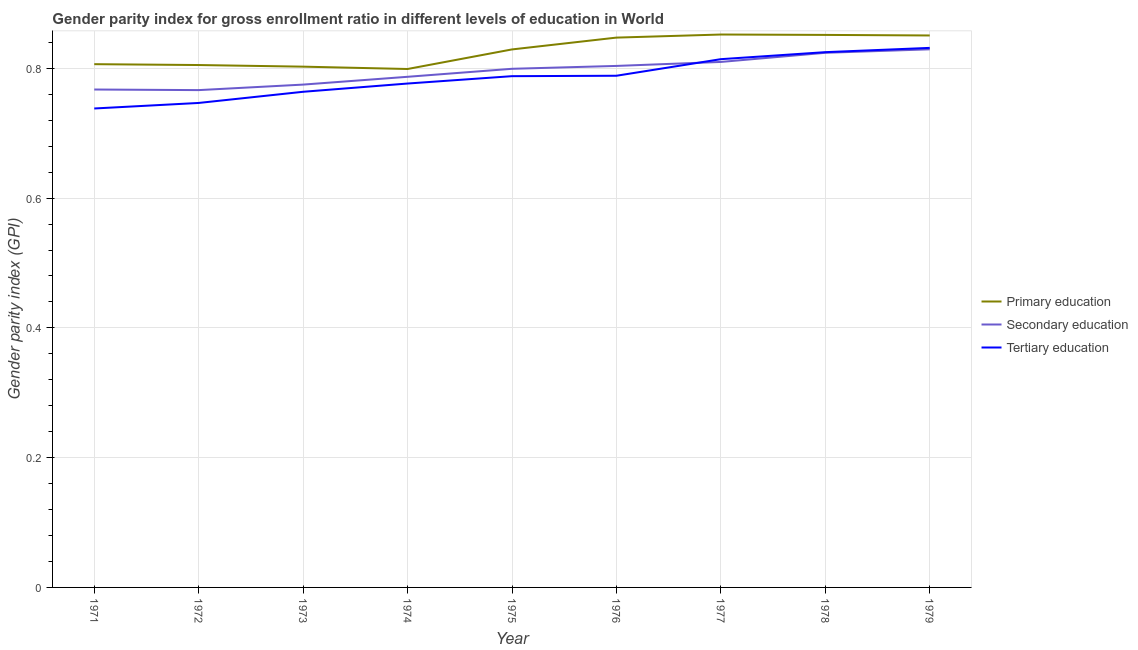Does the line corresponding to gender parity index in primary education intersect with the line corresponding to gender parity index in secondary education?
Your answer should be very brief. No. What is the gender parity index in primary education in 1976?
Offer a terse response. 0.85. Across all years, what is the maximum gender parity index in tertiary education?
Offer a terse response. 0.83. Across all years, what is the minimum gender parity index in secondary education?
Keep it short and to the point. 0.77. In which year was the gender parity index in tertiary education maximum?
Provide a succinct answer. 1979. In which year was the gender parity index in primary education minimum?
Provide a short and direct response. 1974. What is the total gender parity index in secondary education in the graph?
Provide a succinct answer. 7.16. What is the difference between the gender parity index in secondary education in 1974 and that in 1977?
Keep it short and to the point. -0.02. What is the difference between the gender parity index in tertiary education in 1975 and the gender parity index in primary education in 1972?
Offer a very short reply. -0.02. What is the average gender parity index in primary education per year?
Provide a short and direct response. 0.83. In the year 1976, what is the difference between the gender parity index in primary education and gender parity index in tertiary education?
Provide a short and direct response. 0.06. In how many years, is the gender parity index in primary education greater than 0.32?
Give a very brief answer. 9. What is the ratio of the gender parity index in secondary education in 1972 to that in 1976?
Give a very brief answer. 0.95. Is the difference between the gender parity index in tertiary education in 1974 and 1979 greater than the difference between the gender parity index in primary education in 1974 and 1979?
Provide a short and direct response. No. What is the difference between the highest and the second highest gender parity index in primary education?
Give a very brief answer. 0. What is the difference between the highest and the lowest gender parity index in secondary education?
Offer a very short reply. 0.06. In how many years, is the gender parity index in primary education greater than the average gender parity index in primary education taken over all years?
Provide a short and direct response. 5. Is the gender parity index in secondary education strictly greater than the gender parity index in tertiary education over the years?
Ensure brevity in your answer.  No. Is the gender parity index in secondary education strictly less than the gender parity index in tertiary education over the years?
Keep it short and to the point. No. Are the values on the major ticks of Y-axis written in scientific E-notation?
Your answer should be compact. No. Where does the legend appear in the graph?
Make the answer very short. Center right. How many legend labels are there?
Offer a terse response. 3. How are the legend labels stacked?
Offer a very short reply. Vertical. What is the title of the graph?
Your response must be concise. Gender parity index for gross enrollment ratio in different levels of education in World. Does "Methane" appear as one of the legend labels in the graph?
Offer a terse response. No. What is the label or title of the Y-axis?
Offer a very short reply. Gender parity index (GPI). What is the Gender parity index (GPI) of Primary education in 1971?
Provide a succinct answer. 0.81. What is the Gender parity index (GPI) of Secondary education in 1971?
Your answer should be very brief. 0.77. What is the Gender parity index (GPI) of Tertiary education in 1971?
Your answer should be very brief. 0.74. What is the Gender parity index (GPI) in Primary education in 1972?
Give a very brief answer. 0.81. What is the Gender parity index (GPI) in Secondary education in 1972?
Provide a short and direct response. 0.77. What is the Gender parity index (GPI) of Tertiary education in 1972?
Keep it short and to the point. 0.75. What is the Gender parity index (GPI) in Primary education in 1973?
Ensure brevity in your answer.  0.8. What is the Gender parity index (GPI) of Secondary education in 1973?
Provide a short and direct response. 0.77. What is the Gender parity index (GPI) of Tertiary education in 1973?
Keep it short and to the point. 0.76. What is the Gender parity index (GPI) of Primary education in 1974?
Give a very brief answer. 0.8. What is the Gender parity index (GPI) in Secondary education in 1974?
Your response must be concise. 0.79. What is the Gender parity index (GPI) in Tertiary education in 1974?
Provide a short and direct response. 0.78. What is the Gender parity index (GPI) in Primary education in 1975?
Provide a short and direct response. 0.83. What is the Gender parity index (GPI) in Secondary education in 1975?
Offer a very short reply. 0.8. What is the Gender parity index (GPI) of Tertiary education in 1975?
Offer a very short reply. 0.79. What is the Gender parity index (GPI) of Primary education in 1976?
Give a very brief answer. 0.85. What is the Gender parity index (GPI) of Secondary education in 1976?
Provide a succinct answer. 0.8. What is the Gender parity index (GPI) in Tertiary education in 1976?
Your answer should be very brief. 0.79. What is the Gender parity index (GPI) in Primary education in 1977?
Offer a terse response. 0.85. What is the Gender parity index (GPI) in Secondary education in 1977?
Ensure brevity in your answer.  0.81. What is the Gender parity index (GPI) of Tertiary education in 1977?
Give a very brief answer. 0.81. What is the Gender parity index (GPI) in Primary education in 1978?
Make the answer very short. 0.85. What is the Gender parity index (GPI) of Secondary education in 1978?
Offer a terse response. 0.82. What is the Gender parity index (GPI) in Tertiary education in 1978?
Ensure brevity in your answer.  0.82. What is the Gender parity index (GPI) of Primary education in 1979?
Make the answer very short. 0.85. What is the Gender parity index (GPI) of Secondary education in 1979?
Your answer should be compact. 0.83. What is the Gender parity index (GPI) of Tertiary education in 1979?
Keep it short and to the point. 0.83. Across all years, what is the maximum Gender parity index (GPI) of Primary education?
Provide a short and direct response. 0.85. Across all years, what is the maximum Gender parity index (GPI) in Secondary education?
Offer a terse response. 0.83. Across all years, what is the maximum Gender parity index (GPI) of Tertiary education?
Offer a very short reply. 0.83. Across all years, what is the minimum Gender parity index (GPI) of Primary education?
Provide a short and direct response. 0.8. Across all years, what is the minimum Gender parity index (GPI) of Secondary education?
Your answer should be compact. 0.77. Across all years, what is the minimum Gender parity index (GPI) of Tertiary education?
Your answer should be compact. 0.74. What is the total Gender parity index (GPI) of Primary education in the graph?
Make the answer very short. 7.44. What is the total Gender parity index (GPI) of Secondary education in the graph?
Offer a terse response. 7.16. What is the total Gender parity index (GPI) in Tertiary education in the graph?
Your answer should be very brief. 7.07. What is the difference between the Gender parity index (GPI) in Primary education in 1971 and that in 1972?
Make the answer very short. 0. What is the difference between the Gender parity index (GPI) in Secondary education in 1971 and that in 1972?
Give a very brief answer. 0. What is the difference between the Gender parity index (GPI) of Tertiary education in 1971 and that in 1972?
Offer a terse response. -0.01. What is the difference between the Gender parity index (GPI) of Primary education in 1971 and that in 1973?
Offer a terse response. 0. What is the difference between the Gender parity index (GPI) of Secondary education in 1971 and that in 1973?
Provide a short and direct response. -0.01. What is the difference between the Gender parity index (GPI) in Tertiary education in 1971 and that in 1973?
Ensure brevity in your answer.  -0.03. What is the difference between the Gender parity index (GPI) in Primary education in 1971 and that in 1974?
Your answer should be very brief. 0.01. What is the difference between the Gender parity index (GPI) in Secondary education in 1971 and that in 1974?
Your answer should be compact. -0.02. What is the difference between the Gender parity index (GPI) in Tertiary education in 1971 and that in 1974?
Your response must be concise. -0.04. What is the difference between the Gender parity index (GPI) of Primary education in 1971 and that in 1975?
Ensure brevity in your answer.  -0.02. What is the difference between the Gender parity index (GPI) in Secondary education in 1971 and that in 1975?
Your answer should be very brief. -0.03. What is the difference between the Gender parity index (GPI) in Tertiary education in 1971 and that in 1975?
Provide a succinct answer. -0.05. What is the difference between the Gender parity index (GPI) of Primary education in 1971 and that in 1976?
Your answer should be compact. -0.04. What is the difference between the Gender parity index (GPI) of Secondary education in 1971 and that in 1976?
Provide a succinct answer. -0.04. What is the difference between the Gender parity index (GPI) in Tertiary education in 1971 and that in 1976?
Your answer should be very brief. -0.05. What is the difference between the Gender parity index (GPI) in Primary education in 1971 and that in 1977?
Your response must be concise. -0.05. What is the difference between the Gender parity index (GPI) in Secondary education in 1971 and that in 1977?
Ensure brevity in your answer.  -0.04. What is the difference between the Gender parity index (GPI) in Tertiary education in 1971 and that in 1977?
Give a very brief answer. -0.08. What is the difference between the Gender parity index (GPI) in Primary education in 1971 and that in 1978?
Offer a very short reply. -0.05. What is the difference between the Gender parity index (GPI) of Secondary education in 1971 and that in 1978?
Give a very brief answer. -0.06. What is the difference between the Gender parity index (GPI) in Tertiary education in 1971 and that in 1978?
Offer a very short reply. -0.09. What is the difference between the Gender parity index (GPI) of Primary education in 1971 and that in 1979?
Provide a succinct answer. -0.04. What is the difference between the Gender parity index (GPI) of Secondary education in 1971 and that in 1979?
Ensure brevity in your answer.  -0.06. What is the difference between the Gender parity index (GPI) in Tertiary education in 1971 and that in 1979?
Provide a short and direct response. -0.09. What is the difference between the Gender parity index (GPI) in Primary education in 1972 and that in 1973?
Your response must be concise. 0. What is the difference between the Gender parity index (GPI) in Secondary education in 1972 and that in 1973?
Offer a terse response. -0.01. What is the difference between the Gender parity index (GPI) of Tertiary education in 1972 and that in 1973?
Give a very brief answer. -0.02. What is the difference between the Gender parity index (GPI) in Primary education in 1972 and that in 1974?
Provide a succinct answer. 0.01. What is the difference between the Gender parity index (GPI) in Secondary education in 1972 and that in 1974?
Offer a terse response. -0.02. What is the difference between the Gender parity index (GPI) in Tertiary education in 1972 and that in 1974?
Offer a terse response. -0.03. What is the difference between the Gender parity index (GPI) in Primary education in 1972 and that in 1975?
Ensure brevity in your answer.  -0.02. What is the difference between the Gender parity index (GPI) in Secondary education in 1972 and that in 1975?
Your response must be concise. -0.03. What is the difference between the Gender parity index (GPI) in Tertiary education in 1972 and that in 1975?
Offer a very short reply. -0.04. What is the difference between the Gender parity index (GPI) in Primary education in 1972 and that in 1976?
Offer a terse response. -0.04. What is the difference between the Gender parity index (GPI) of Secondary education in 1972 and that in 1976?
Provide a short and direct response. -0.04. What is the difference between the Gender parity index (GPI) in Tertiary education in 1972 and that in 1976?
Ensure brevity in your answer.  -0.04. What is the difference between the Gender parity index (GPI) of Primary education in 1972 and that in 1977?
Provide a short and direct response. -0.05. What is the difference between the Gender parity index (GPI) in Secondary education in 1972 and that in 1977?
Your response must be concise. -0.04. What is the difference between the Gender parity index (GPI) in Tertiary education in 1972 and that in 1977?
Make the answer very short. -0.07. What is the difference between the Gender parity index (GPI) of Primary education in 1972 and that in 1978?
Offer a terse response. -0.05. What is the difference between the Gender parity index (GPI) of Secondary education in 1972 and that in 1978?
Your answer should be very brief. -0.06. What is the difference between the Gender parity index (GPI) of Tertiary education in 1972 and that in 1978?
Give a very brief answer. -0.08. What is the difference between the Gender parity index (GPI) in Primary education in 1972 and that in 1979?
Your response must be concise. -0.05. What is the difference between the Gender parity index (GPI) in Secondary education in 1972 and that in 1979?
Provide a succinct answer. -0.06. What is the difference between the Gender parity index (GPI) in Tertiary education in 1972 and that in 1979?
Your response must be concise. -0.08. What is the difference between the Gender parity index (GPI) of Primary education in 1973 and that in 1974?
Your answer should be very brief. 0. What is the difference between the Gender parity index (GPI) in Secondary education in 1973 and that in 1974?
Offer a very short reply. -0.01. What is the difference between the Gender parity index (GPI) in Tertiary education in 1973 and that in 1974?
Your response must be concise. -0.01. What is the difference between the Gender parity index (GPI) of Primary education in 1973 and that in 1975?
Keep it short and to the point. -0.03. What is the difference between the Gender parity index (GPI) in Secondary education in 1973 and that in 1975?
Ensure brevity in your answer.  -0.02. What is the difference between the Gender parity index (GPI) in Tertiary education in 1973 and that in 1975?
Your answer should be compact. -0.02. What is the difference between the Gender parity index (GPI) in Primary education in 1973 and that in 1976?
Provide a short and direct response. -0.04. What is the difference between the Gender parity index (GPI) of Secondary education in 1973 and that in 1976?
Make the answer very short. -0.03. What is the difference between the Gender parity index (GPI) in Tertiary education in 1973 and that in 1976?
Your answer should be very brief. -0.02. What is the difference between the Gender parity index (GPI) in Primary education in 1973 and that in 1977?
Ensure brevity in your answer.  -0.05. What is the difference between the Gender parity index (GPI) in Secondary education in 1973 and that in 1977?
Provide a succinct answer. -0.03. What is the difference between the Gender parity index (GPI) of Tertiary education in 1973 and that in 1977?
Provide a short and direct response. -0.05. What is the difference between the Gender parity index (GPI) in Primary education in 1973 and that in 1978?
Make the answer very short. -0.05. What is the difference between the Gender parity index (GPI) in Secondary education in 1973 and that in 1978?
Keep it short and to the point. -0.05. What is the difference between the Gender parity index (GPI) of Tertiary education in 1973 and that in 1978?
Your answer should be very brief. -0.06. What is the difference between the Gender parity index (GPI) of Primary education in 1973 and that in 1979?
Provide a short and direct response. -0.05. What is the difference between the Gender parity index (GPI) in Secondary education in 1973 and that in 1979?
Your answer should be compact. -0.05. What is the difference between the Gender parity index (GPI) in Tertiary education in 1973 and that in 1979?
Offer a very short reply. -0.07. What is the difference between the Gender parity index (GPI) of Primary education in 1974 and that in 1975?
Provide a succinct answer. -0.03. What is the difference between the Gender parity index (GPI) in Secondary education in 1974 and that in 1975?
Provide a succinct answer. -0.01. What is the difference between the Gender parity index (GPI) of Tertiary education in 1974 and that in 1975?
Your answer should be very brief. -0.01. What is the difference between the Gender parity index (GPI) of Primary education in 1974 and that in 1976?
Offer a very short reply. -0.05. What is the difference between the Gender parity index (GPI) in Secondary education in 1974 and that in 1976?
Your response must be concise. -0.02. What is the difference between the Gender parity index (GPI) in Tertiary education in 1974 and that in 1976?
Provide a short and direct response. -0.01. What is the difference between the Gender parity index (GPI) in Primary education in 1974 and that in 1977?
Your response must be concise. -0.05. What is the difference between the Gender parity index (GPI) of Secondary education in 1974 and that in 1977?
Provide a succinct answer. -0.02. What is the difference between the Gender parity index (GPI) of Tertiary education in 1974 and that in 1977?
Your answer should be compact. -0.04. What is the difference between the Gender parity index (GPI) in Primary education in 1974 and that in 1978?
Offer a terse response. -0.05. What is the difference between the Gender parity index (GPI) of Secondary education in 1974 and that in 1978?
Your response must be concise. -0.04. What is the difference between the Gender parity index (GPI) of Tertiary education in 1974 and that in 1978?
Offer a terse response. -0.05. What is the difference between the Gender parity index (GPI) of Primary education in 1974 and that in 1979?
Your response must be concise. -0.05. What is the difference between the Gender parity index (GPI) in Secondary education in 1974 and that in 1979?
Ensure brevity in your answer.  -0.04. What is the difference between the Gender parity index (GPI) of Tertiary education in 1974 and that in 1979?
Provide a short and direct response. -0.06. What is the difference between the Gender parity index (GPI) of Primary education in 1975 and that in 1976?
Your answer should be compact. -0.02. What is the difference between the Gender parity index (GPI) in Secondary education in 1975 and that in 1976?
Provide a short and direct response. -0. What is the difference between the Gender parity index (GPI) in Tertiary education in 1975 and that in 1976?
Your answer should be compact. -0. What is the difference between the Gender parity index (GPI) in Primary education in 1975 and that in 1977?
Your response must be concise. -0.02. What is the difference between the Gender parity index (GPI) of Secondary education in 1975 and that in 1977?
Offer a very short reply. -0.01. What is the difference between the Gender parity index (GPI) in Tertiary education in 1975 and that in 1977?
Make the answer very short. -0.03. What is the difference between the Gender parity index (GPI) of Primary education in 1975 and that in 1978?
Keep it short and to the point. -0.02. What is the difference between the Gender parity index (GPI) of Secondary education in 1975 and that in 1978?
Ensure brevity in your answer.  -0.02. What is the difference between the Gender parity index (GPI) in Tertiary education in 1975 and that in 1978?
Offer a very short reply. -0.04. What is the difference between the Gender parity index (GPI) of Primary education in 1975 and that in 1979?
Offer a terse response. -0.02. What is the difference between the Gender parity index (GPI) of Secondary education in 1975 and that in 1979?
Offer a very short reply. -0.03. What is the difference between the Gender parity index (GPI) of Tertiary education in 1975 and that in 1979?
Your answer should be compact. -0.04. What is the difference between the Gender parity index (GPI) in Primary education in 1976 and that in 1977?
Give a very brief answer. -0. What is the difference between the Gender parity index (GPI) in Secondary education in 1976 and that in 1977?
Make the answer very short. -0.01. What is the difference between the Gender parity index (GPI) in Tertiary education in 1976 and that in 1977?
Your answer should be very brief. -0.03. What is the difference between the Gender parity index (GPI) of Primary education in 1976 and that in 1978?
Provide a succinct answer. -0. What is the difference between the Gender parity index (GPI) of Secondary education in 1976 and that in 1978?
Your answer should be compact. -0.02. What is the difference between the Gender parity index (GPI) of Tertiary education in 1976 and that in 1978?
Your response must be concise. -0.04. What is the difference between the Gender parity index (GPI) in Primary education in 1976 and that in 1979?
Keep it short and to the point. -0. What is the difference between the Gender parity index (GPI) in Secondary education in 1976 and that in 1979?
Keep it short and to the point. -0.03. What is the difference between the Gender parity index (GPI) in Tertiary education in 1976 and that in 1979?
Offer a very short reply. -0.04. What is the difference between the Gender parity index (GPI) in Primary education in 1977 and that in 1978?
Your response must be concise. 0. What is the difference between the Gender parity index (GPI) in Secondary education in 1977 and that in 1978?
Make the answer very short. -0.01. What is the difference between the Gender parity index (GPI) of Tertiary education in 1977 and that in 1978?
Make the answer very short. -0.01. What is the difference between the Gender parity index (GPI) of Primary education in 1977 and that in 1979?
Your answer should be compact. 0. What is the difference between the Gender parity index (GPI) in Secondary education in 1977 and that in 1979?
Your answer should be compact. -0.02. What is the difference between the Gender parity index (GPI) in Tertiary education in 1977 and that in 1979?
Your answer should be very brief. -0.02. What is the difference between the Gender parity index (GPI) in Primary education in 1978 and that in 1979?
Give a very brief answer. 0. What is the difference between the Gender parity index (GPI) of Secondary education in 1978 and that in 1979?
Your answer should be very brief. -0.01. What is the difference between the Gender parity index (GPI) of Tertiary education in 1978 and that in 1979?
Offer a very short reply. -0.01. What is the difference between the Gender parity index (GPI) of Primary education in 1971 and the Gender parity index (GPI) of Secondary education in 1972?
Offer a terse response. 0.04. What is the difference between the Gender parity index (GPI) of Primary education in 1971 and the Gender parity index (GPI) of Tertiary education in 1972?
Keep it short and to the point. 0.06. What is the difference between the Gender parity index (GPI) in Secondary education in 1971 and the Gender parity index (GPI) in Tertiary education in 1972?
Keep it short and to the point. 0.02. What is the difference between the Gender parity index (GPI) of Primary education in 1971 and the Gender parity index (GPI) of Secondary education in 1973?
Offer a terse response. 0.03. What is the difference between the Gender parity index (GPI) in Primary education in 1971 and the Gender parity index (GPI) in Tertiary education in 1973?
Give a very brief answer. 0.04. What is the difference between the Gender parity index (GPI) in Secondary education in 1971 and the Gender parity index (GPI) in Tertiary education in 1973?
Your response must be concise. 0. What is the difference between the Gender parity index (GPI) in Primary education in 1971 and the Gender parity index (GPI) in Secondary education in 1974?
Your response must be concise. 0.02. What is the difference between the Gender parity index (GPI) of Primary education in 1971 and the Gender parity index (GPI) of Tertiary education in 1974?
Your answer should be compact. 0.03. What is the difference between the Gender parity index (GPI) in Secondary education in 1971 and the Gender parity index (GPI) in Tertiary education in 1974?
Your response must be concise. -0.01. What is the difference between the Gender parity index (GPI) in Primary education in 1971 and the Gender parity index (GPI) in Secondary education in 1975?
Provide a succinct answer. 0.01. What is the difference between the Gender parity index (GPI) of Primary education in 1971 and the Gender parity index (GPI) of Tertiary education in 1975?
Make the answer very short. 0.02. What is the difference between the Gender parity index (GPI) of Secondary education in 1971 and the Gender parity index (GPI) of Tertiary education in 1975?
Provide a short and direct response. -0.02. What is the difference between the Gender parity index (GPI) in Primary education in 1971 and the Gender parity index (GPI) in Secondary education in 1976?
Provide a short and direct response. 0. What is the difference between the Gender parity index (GPI) of Primary education in 1971 and the Gender parity index (GPI) of Tertiary education in 1976?
Keep it short and to the point. 0.02. What is the difference between the Gender parity index (GPI) in Secondary education in 1971 and the Gender parity index (GPI) in Tertiary education in 1976?
Your answer should be very brief. -0.02. What is the difference between the Gender parity index (GPI) of Primary education in 1971 and the Gender parity index (GPI) of Secondary education in 1977?
Offer a terse response. -0. What is the difference between the Gender parity index (GPI) of Primary education in 1971 and the Gender parity index (GPI) of Tertiary education in 1977?
Provide a short and direct response. -0.01. What is the difference between the Gender parity index (GPI) in Secondary education in 1971 and the Gender parity index (GPI) in Tertiary education in 1977?
Your response must be concise. -0.05. What is the difference between the Gender parity index (GPI) in Primary education in 1971 and the Gender parity index (GPI) in Secondary education in 1978?
Offer a very short reply. -0.02. What is the difference between the Gender parity index (GPI) in Primary education in 1971 and the Gender parity index (GPI) in Tertiary education in 1978?
Offer a terse response. -0.02. What is the difference between the Gender parity index (GPI) of Secondary education in 1971 and the Gender parity index (GPI) of Tertiary education in 1978?
Your answer should be compact. -0.06. What is the difference between the Gender parity index (GPI) in Primary education in 1971 and the Gender parity index (GPI) in Secondary education in 1979?
Your answer should be very brief. -0.02. What is the difference between the Gender parity index (GPI) of Primary education in 1971 and the Gender parity index (GPI) of Tertiary education in 1979?
Your answer should be compact. -0.03. What is the difference between the Gender parity index (GPI) of Secondary education in 1971 and the Gender parity index (GPI) of Tertiary education in 1979?
Offer a very short reply. -0.06. What is the difference between the Gender parity index (GPI) of Primary education in 1972 and the Gender parity index (GPI) of Secondary education in 1973?
Keep it short and to the point. 0.03. What is the difference between the Gender parity index (GPI) of Primary education in 1972 and the Gender parity index (GPI) of Tertiary education in 1973?
Keep it short and to the point. 0.04. What is the difference between the Gender parity index (GPI) in Secondary education in 1972 and the Gender parity index (GPI) in Tertiary education in 1973?
Your response must be concise. 0. What is the difference between the Gender parity index (GPI) of Primary education in 1972 and the Gender parity index (GPI) of Secondary education in 1974?
Provide a short and direct response. 0.02. What is the difference between the Gender parity index (GPI) in Primary education in 1972 and the Gender parity index (GPI) in Tertiary education in 1974?
Keep it short and to the point. 0.03. What is the difference between the Gender parity index (GPI) in Secondary education in 1972 and the Gender parity index (GPI) in Tertiary education in 1974?
Provide a short and direct response. -0.01. What is the difference between the Gender parity index (GPI) in Primary education in 1972 and the Gender parity index (GPI) in Secondary education in 1975?
Your answer should be very brief. 0.01. What is the difference between the Gender parity index (GPI) in Primary education in 1972 and the Gender parity index (GPI) in Tertiary education in 1975?
Keep it short and to the point. 0.02. What is the difference between the Gender parity index (GPI) of Secondary education in 1972 and the Gender parity index (GPI) of Tertiary education in 1975?
Your answer should be compact. -0.02. What is the difference between the Gender parity index (GPI) in Primary education in 1972 and the Gender parity index (GPI) in Secondary education in 1976?
Offer a terse response. 0. What is the difference between the Gender parity index (GPI) of Primary education in 1972 and the Gender parity index (GPI) of Tertiary education in 1976?
Your answer should be very brief. 0.02. What is the difference between the Gender parity index (GPI) of Secondary education in 1972 and the Gender parity index (GPI) of Tertiary education in 1976?
Keep it short and to the point. -0.02. What is the difference between the Gender parity index (GPI) of Primary education in 1972 and the Gender parity index (GPI) of Secondary education in 1977?
Give a very brief answer. -0. What is the difference between the Gender parity index (GPI) in Primary education in 1972 and the Gender parity index (GPI) in Tertiary education in 1977?
Your answer should be compact. -0.01. What is the difference between the Gender parity index (GPI) in Secondary education in 1972 and the Gender parity index (GPI) in Tertiary education in 1977?
Keep it short and to the point. -0.05. What is the difference between the Gender parity index (GPI) of Primary education in 1972 and the Gender parity index (GPI) of Secondary education in 1978?
Give a very brief answer. -0.02. What is the difference between the Gender parity index (GPI) in Primary education in 1972 and the Gender parity index (GPI) in Tertiary education in 1978?
Offer a very short reply. -0.02. What is the difference between the Gender parity index (GPI) of Secondary education in 1972 and the Gender parity index (GPI) of Tertiary education in 1978?
Provide a short and direct response. -0.06. What is the difference between the Gender parity index (GPI) of Primary education in 1972 and the Gender parity index (GPI) of Secondary education in 1979?
Your answer should be compact. -0.02. What is the difference between the Gender parity index (GPI) of Primary education in 1972 and the Gender parity index (GPI) of Tertiary education in 1979?
Give a very brief answer. -0.03. What is the difference between the Gender parity index (GPI) in Secondary education in 1972 and the Gender parity index (GPI) in Tertiary education in 1979?
Ensure brevity in your answer.  -0.07. What is the difference between the Gender parity index (GPI) in Primary education in 1973 and the Gender parity index (GPI) in Secondary education in 1974?
Offer a very short reply. 0.02. What is the difference between the Gender parity index (GPI) in Primary education in 1973 and the Gender parity index (GPI) in Tertiary education in 1974?
Provide a short and direct response. 0.03. What is the difference between the Gender parity index (GPI) in Secondary education in 1973 and the Gender parity index (GPI) in Tertiary education in 1974?
Make the answer very short. -0. What is the difference between the Gender parity index (GPI) of Primary education in 1973 and the Gender parity index (GPI) of Secondary education in 1975?
Your answer should be very brief. 0. What is the difference between the Gender parity index (GPI) of Primary education in 1973 and the Gender parity index (GPI) of Tertiary education in 1975?
Offer a very short reply. 0.01. What is the difference between the Gender parity index (GPI) of Secondary education in 1973 and the Gender parity index (GPI) of Tertiary education in 1975?
Your answer should be compact. -0.01. What is the difference between the Gender parity index (GPI) of Primary education in 1973 and the Gender parity index (GPI) of Secondary education in 1976?
Give a very brief answer. -0. What is the difference between the Gender parity index (GPI) of Primary education in 1973 and the Gender parity index (GPI) of Tertiary education in 1976?
Your response must be concise. 0.01. What is the difference between the Gender parity index (GPI) in Secondary education in 1973 and the Gender parity index (GPI) in Tertiary education in 1976?
Keep it short and to the point. -0.01. What is the difference between the Gender parity index (GPI) of Primary education in 1973 and the Gender parity index (GPI) of Secondary education in 1977?
Keep it short and to the point. -0.01. What is the difference between the Gender parity index (GPI) in Primary education in 1973 and the Gender parity index (GPI) in Tertiary education in 1977?
Give a very brief answer. -0.01. What is the difference between the Gender parity index (GPI) of Secondary education in 1973 and the Gender parity index (GPI) of Tertiary education in 1977?
Make the answer very short. -0.04. What is the difference between the Gender parity index (GPI) in Primary education in 1973 and the Gender parity index (GPI) in Secondary education in 1978?
Your response must be concise. -0.02. What is the difference between the Gender parity index (GPI) of Primary education in 1973 and the Gender parity index (GPI) of Tertiary education in 1978?
Your answer should be compact. -0.02. What is the difference between the Gender parity index (GPI) in Secondary education in 1973 and the Gender parity index (GPI) in Tertiary education in 1978?
Make the answer very short. -0.05. What is the difference between the Gender parity index (GPI) of Primary education in 1973 and the Gender parity index (GPI) of Secondary education in 1979?
Ensure brevity in your answer.  -0.03. What is the difference between the Gender parity index (GPI) of Primary education in 1973 and the Gender parity index (GPI) of Tertiary education in 1979?
Your answer should be very brief. -0.03. What is the difference between the Gender parity index (GPI) in Secondary education in 1973 and the Gender parity index (GPI) in Tertiary education in 1979?
Provide a succinct answer. -0.06. What is the difference between the Gender parity index (GPI) in Primary education in 1974 and the Gender parity index (GPI) in Secondary education in 1975?
Your answer should be compact. -0. What is the difference between the Gender parity index (GPI) in Primary education in 1974 and the Gender parity index (GPI) in Tertiary education in 1975?
Provide a succinct answer. 0.01. What is the difference between the Gender parity index (GPI) of Secondary education in 1974 and the Gender parity index (GPI) of Tertiary education in 1975?
Provide a succinct answer. -0. What is the difference between the Gender parity index (GPI) in Primary education in 1974 and the Gender parity index (GPI) in Secondary education in 1976?
Offer a very short reply. -0. What is the difference between the Gender parity index (GPI) in Primary education in 1974 and the Gender parity index (GPI) in Tertiary education in 1976?
Offer a terse response. 0.01. What is the difference between the Gender parity index (GPI) in Secondary education in 1974 and the Gender parity index (GPI) in Tertiary education in 1976?
Make the answer very short. -0. What is the difference between the Gender parity index (GPI) in Primary education in 1974 and the Gender parity index (GPI) in Secondary education in 1977?
Offer a very short reply. -0.01. What is the difference between the Gender parity index (GPI) of Primary education in 1974 and the Gender parity index (GPI) of Tertiary education in 1977?
Give a very brief answer. -0.02. What is the difference between the Gender parity index (GPI) of Secondary education in 1974 and the Gender parity index (GPI) of Tertiary education in 1977?
Offer a very short reply. -0.03. What is the difference between the Gender parity index (GPI) of Primary education in 1974 and the Gender parity index (GPI) of Secondary education in 1978?
Provide a short and direct response. -0.03. What is the difference between the Gender parity index (GPI) of Primary education in 1974 and the Gender parity index (GPI) of Tertiary education in 1978?
Your answer should be compact. -0.03. What is the difference between the Gender parity index (GPI) of Secondary education in 1974 and the Gender parity index (GPI) of Tertiary education in 1978?
Ensure brevity in your answer.  -0.04. What is the difference between the Gender parity index (GPI) in Primary education in 1974 and the Gender parity index (GPI) in Secondary education in 1979?
Your answer should be compact. -0.03. What is the difference between the Gender parity index (GPI) of Primary education in 1974 and the Gender parity index (GPI) of Tertiary education in 1979?
Provide a succinct answer. -0.03. What is the difference between the Gender parity index (GPI) in Secondary education in 1974 and the Gender parity index (GPI) in Tertiary education in 1979?
Give a very brief answer. -0.04. What is the difference between the Gender parity index (GPI) of Primary education in 1975 and the Gender parity index (GPI) of Secondary education in 1976?
Your response must be concise. 0.03. What is the difference between the Gender parity index (GPI) in Primary education in 1975 and the Gender parity index (GPI) in Tertiary education in 1976?
Keep it short and to the point. 0.04. What is the difference between the Gender parity index (GPI) in Secondary education in 1975 and the Gender parity index (GPI) in Tertiary education in 1976?
Your response must be concise. 0.01. What is the difference between the Gender parity index (GPI) of Primary education in 1975 and the Gender parity index (GPI) of Secondary education in 1977?
Your answer should be very brief. 0.02. What is the difference between the Gender parity index (GPI) in Primary education in 1975 and the Gender parity index (GPI) in Tertiary education in 1977?
Your answer should be compact. 0.01. What is the difference between the Gender parity index (GPI) of Secondary education in 1975 and the Gender parity index (GPI) of Tertiary education in 1977?
Provide a short and direct response. -0.01. What is the difference between the Gender parity index (GPI) of Primary education in 1975 and the Gender parity index (GPI) of Secondary education in 1978?
Keep it short and to the point. 0.01. What is the difference between the Gender parity index (GPI) in Primary education in 1975 and the Gender parity index (GPI) in Tertiary education in 1978?
Give a very brief answer. 0. What is the difference between the Gender parity index (GPI) in Secondary education in 1975 and the Gender parity index (GPI) in Tertiary education in 1978?
Your response must be concise. -0.03. What is the difference between the Gender parity index (GPI) in Primary education in 1975 and the Gender parity index (GPI) in Secondary education in 1979?
Your answer should be very brief. -0. What is the difference between the Gender parity index (GPI) in Primary education in 1975 and the Gender parity index (GPI) in Tertiary education in 1979?
Your answer should be compact. -0. What is the difference between the Gender parity index (GPI) in Secondary education in 1975 and the Gender parity index (GPI) in Tertiary education in 1979?
Make the answer very short. -0.03. What is the difference between the Gender parity index (GPI) of Primary education in 1976 and the Gender parity index (GPI) of Secondary education in 1977?
Make the answer very short. 0.04. What is the difference between the Gender parity index (GPI) of Primary education in 1976 and the Gender parity index (GPI) of Tertiary education in 1977?
Give a very brief answer. 0.03. What is the difference between the Gender parity index (GPI) in Secondary education in 1976 and the Gender parity index (GPI) in Tertiary education in 1977?
Offer a very short reply. -0.01. What is the difference between the Gender parity index (GPI) of Primary education in 1976 and the Gender parity index (GPI) of Secondary education in 1978?
Your answer should be very brief. 0.02. What is the difference between the Gender parity index (GPI) in Primary education in 1976 and the Gender parity index (GPI) in Tertiary education in 1978?
Provide a short and direct response. 0.02. What is the difference between the Gender parity index (GPI) in Secondary education in 1976 and the Gender parity index (GPI) in Tertiary education in 1978?
Your answer should be very brief. -0.02. What is the difference between the Gender parity index (GPI) in Primary education in 1976 and the Gender parity index (GPI) in Secondary education in 1979?
Your answer should be compact. 0.02. What is the difference between the Gender parity index (GPI) in Primary education in 1976 and the Gender parity index (GPI) in Tertiary education in 1979?
Ensure brevity in your answer.  0.02. What is the difference between the Gender parity index (GPI) of Secondary education in 1976 and the Gender parity index (GPI) of Tertiary education in 1979?
Your answer should be very brief. -0.03. What is the difference between the Gender parity index (GPI) of Primary education in 1977 and the Gender parity index (GPI) of Secondary education in 1978?
Make the answer very short. 0.03. What is the difference between the Gender parity index (GPI) in Primary education in 1977 and the Gender parity index (GPI) in Tertiary education in 1978?
Give a very brief answer. 0.03. What is the difference between the Gender parity index (GPI) in Secondary education in 1977 and the Gender parity index (GPI) in Tertiary education in 1978?
Offer a very short reply. -0.02. What is the difference between the Gender parity index (GPI) of Primary education in 1977 and the Gender parity index (GPI) of Secondary education in 1979?
Keep it short and to the point. 0.02. What is the difference between the Gender parity index (GPI) in Primary education in 1977 and the Gender parity index (GPI) in Tertiary education in 1979?
Your answer should be compact. 0.02. What is the difference between the Gender parity index (GPI) in Secondary education in 1977 and the Gender parity index (GPI) in Tertiary education in 1979?
Ensure brevity in your answer.  -0.02. What is the difference between the Gender parity index (GPI) of Primary education in 1978 and the Gender parity index (GPI) of Secondary education in 1979?
Provide a short and direct response. 0.02. What is the difference between the Gender parity index (GPI) in Primary education in 1978 and the Gender parity index (GPI) in Tertiary education in 1979?
Make the answer very short. 0.02. What is the difference between the Gender parity index (GPI) of Secondary education in 1978 and the Gender parity index (GPI) of Tertiary education in 1979?
Keep it short and to the point. -0.01. What is the average Gender parity index (GPI) in Primary education per year?
Offer a terse response. 0.83. What is the average Gender parity index (GPI) of Secondary education per year?
Your response must be concise. 0.8. What is the average Gender parity index (GPI) in Tertiary education per year?
Offer a very short reply. 0.79. In the year 1971, what is the difference between the Gender parity index (GPI) in Primary education and Gender parity index (GPI) in Secondary education?
Your answer should be compact. 0.04. In the year 1971, what is the difference between the Gender parity index (GPI) of Primary education and Gender parity index (GPI) of Tertiary education?
Offer a very short reply. 0.07. In the year 1971, what is the difference between the Gender parity index (GPI) of Secondary education and Gender parity index (GPI) of Tertiary education?
Offer a very short reply. 0.03. In the year 1972, what is the difference between the Gender parity index (GPI) of Primary education and Gender parity index (GPI) of Secondary education?
Give a very brief answer. 0.04. In the year 1972, what is the difference between the Gender parity index (GPI) of Primary education and Gender parity index (GPI) of Tertiary education?
Your answer should be compact. 0.06. In the year 1972, what is the difference between the Gender parity index (GPI) in Secondary education and Gender parity index (GPI) in Tertiary education?
Your answer should be compact. 0.02. In the year 1973, what is the difference between the Gender parity index (GPI) of Primary education and Gender parity index (GPI) of Secondary education?
Provide a succinct answer. 0.03. In the year 1973, what is the difference between the Gender parity index (GPI) in Primary education and Gender parity index (GPI) in Tertiary education?
Make the answer very short. 0.04. In the year 1973, what is the difference between the Gender parity index (GPI) in Secondary education and Gender parity index (GPI) in Tertiary education?
Your answer should be compact. 0.01. In the year 1974, what is the difference between the Gender parity index (GPI) in Primary education and Gender parity index (GPI) in Secondary education?
Ensure brevity in your answer.  0.01. In the year 1974, what is the difference between the Gender parity index (GPI) of Primary education and Gender parity index (GPI) of Tertiary education?
Offer a terse response. 0.02. In the year 1974, what is the difference between the Gender parity index (GPI) in Secondary education and Gender parity index (GPI) in Tertiary education?
Ensure brevity in your answer.  0.01. In the year 1975, what is the difference between the Gender parity index (GPI) of Primary education and Gender parity index (GPI) of Secondary education?
Make the answer very short. 0.03. In the year 1975, what is the difference between the Gender parity index (GPI) in Primary education and Gender parity index (GPI) in Tertiary education?
Your answer should be very brief. 0.04. In the year 1975, what is the difference between the Gender parity index (GPI) in Secondary education and Gender parity index (GPI) in Tertiary education?
Your answer should be compact. 0.01. In the year 1976, what is the difference between the Gender parity index (GPI) of Primary education and Gender parity index (GPI) of Secondary education?
Offer a very short reply. 0.04. In the year 1976, what is the difference between the Gender parity index (GPI) in Primary education and Gender parity index (GPI) in Tertiary education?
Provide a succinct answer. 0.06. In the year 1976, what is the difference between the Gender parity index (GPI) of Secondary education and Gender parity index (GPI) of Tertiary education?
Give a very brief answer. 0.02. In the year 1977, what is the difference between the Gender parity index (GPI) of Primary education and Gender parity index (GPI) of Secondary education?
Ensure brevity in your answer.  0.04. In the year 1977, what is the difference between the Gender parity index (GPI) in Primary education and Gender parity index (GPI) in Tertiary education?
Make the answer very short. 0.04. In the year 1977, what is the difference between the Gender parity index (GPI) in Secondary education and Gender parity index (GPI) in Tertiary education?
Ensure brevity in your answer.  -0. In the year 1978, what is the difference between the Gender parity index (GPI) of Primary education and Gender parity index (GPI) of Secondary education?
Give a very brief answer. 0.03. In the year 1978, what is the difference between the Gender parity index (GPI) of Primary education and Gender parity index (GPI) of Tertiary education?
Ensure brevity in your answer.  0.03. In the year 1978, what is the difference between the Gender parity index (GPI) in Secondary education and Gender parity index (GPI) in Tertiary education?
Give a very brief answer. -0. In the year 1979, what is the difference between the Gender parity index (GPI) of Primary education and Gender parity index (GPI) of Secondary education?
Provide a succinct answer. 0.02. In the year 1979, what is the difference between the Gender parity index (GPI) of Primary education and Gender parity index (GPI) of Tertiary education?
Provide a short and direct response. 0.02. In the year 1979, what is the difference between the Gender parity index (GPI) in Secondary education and Gender parity index (GPI) in Tertiary education?
Your response must be concise. -0. What is the ratio of the Gender parity index (GPI) of Secondary education in 1971 to that in 1972?
Give a very brief answer. 1. What is the ratio of the Gender parity index (GPI) in Primary education in 1971 to that in 1973?
Your answer should be compact. 1. What is the ratio of the Gender parity index (GPI) of Secondary education in 1971 to that in 1973?
Make the answer very short. 0.99. What is the ratio of the Gender parity index (GPI) in Tertiary education in 1971 to that in 1973?
Offer a very short reply. 0.97. What is the ratio of the Gender parity index (GPI) in Primary education in 1971 to that in 1974?
Your answer should be compact. 1.01. What is the ratio of the Gender parity index (GPI) in Secondary education in 1971 to that in 1974?
Offer a very short reply. 0.98. What is the ratio of the Gender parity index (GPI) of Tertiary education in 1971 to that in 1974?
Ensure brevity in your answer.  0.95. What is the ratio of the Gender parity index (GPI) in Primary education in 1971 to that in 1975?
Provide a short and direct response. 0.97. What is the ratio of the Gender parity index (GPI) of Secondary education in 1971 to that in 1975?
Your answer should be compact. 0.96. What is the ratio of the Gender parity index (GPI) of Tertiary education in 1971 to that in 1975?
Keep it short and to the point. 0.94. What is the ratio of the Gender parity index (GPI) in Primary education in 1971 to that in 1976?
Ensure brevity in your answer.  0.95. What is the ratio of the Gender parity index (GPI) of Secondary education in 1971 to that in 1976?
Offer a very short reply. 0.95. What is the ratio of the Gender parity index (GPI) of Tertiary education in 1971 to that in 1976?
Ensure brevity in your answer.  0.94. What is the ratio of the Gender parity index (GPI) of Primary education in 1971 to that in 1977?
Your answer should be very brief. 0.95. What is the ratio of the Gender parity index (GPI) of Secondary education in 1971 to that in 1977?
Your answer should be very brief. 0.95. What is the ratio of the Gender parity index (GPI) in Tertiary education in 1971 to that in 1977?
Keep it short and to the point. 0.91. What is the ratio of the Gender parity index (GPI) of Primary education in 1971 to that in 1978?
Give a very brief answer. 0.95. What is the ratio of the Gender parity index (GPI) in Secondary education in 1971 to that in 1978?
Provide a succinct answer. 0.93. What is the ratio of the Gender parity index (GPI) of Tertiary education in 1971 to that in 1978?
Your answer should be very brief. 0.89. What is the ratio of the Gender parity index (GPI) in Primary education in 1971 to that in 1979?
Your response must be concise. 0.95. What is the ratio of the Gender parity index (GPI) of Secondary education in 1971 to that in 1979?
Your answer should be compact. 0.93. What is the ratio of the Gender parity index (GPI) of Tertiary education in 1971 to that in 1979?
Your response must be concise. 0.89. What is the ratio of the Gender parity index (GPI) of Primary education in 1972 to that in 1973?
Your answer should be very brief. 1. What is the ratio of the Gender parity index (GPI) in Secondary education in 1972 to that in 1973?
Offer a very short reply. 0.99. What is the ratio of the Gender parity index (GPI) of Tertiary education in 1972 to that in 1973?
Your answer should be very brief. 0.98. What is the ratio of the Gender parity index (GPI) of Primary education in 1972 to that in 1974?
Offer a very short reply. 1.01. What is the ratio of the Gender parity index (GPI) in Secondary education in 1972 to that in 1974?
Keep it short and to the point. 0.97. What is the ratio of the Gender parity index (GPI) in Tertiary education in 1972 to that in 1974?
Ensure brevity in your answer.  0.96. What is the ratio of the Gender parity index (GPI) in Primary education in 1972 to that in 1975?
Provide a succinct answer. 0.97. What is the ratio of the Gender parity index (GPI) in Secondary education in 1972 to that in 1975?
Provide a succinct answer. 0.96. What is the ratio of the Gender parity index (GPI) in Tertiary education in 1972 to that in 1975?
Make the answer very short. 0.95. What is the ratio of the Gender parity index (GPI) of Primary education in 1972 to that in 1976?
Offer a very short reply. 0.95. What is the ratio of the Gender parity index (GPI) of Secondary education in 1972 to that in 1976?
Your answer should be compact. 0.95. What is the ratio of the Gender parity index (GPI) in Tertiary education in 1972 to that in 1976?
Provide a succinct answer. 0.95. What is the ratio of the Gender parity index (GPI) of Primary education in 1972 to that in 1977?
Offer a terse response. 0.94. What is the ratio of the Gender parity index (GPI) of Secondary education in 1972 to that in 1977?
Your answer should be compact. 0.95. What is the ratio of the Gender parity index (GPI) in Tertiary education in 1972 to that in 1977?
Provide a succinct answer. 0.92. What is the ratio of the Gender parity index (GPI) in Primary education in 1972 to that in 1978?
Your answer should be compact. 0.95. What is the ratio of the Gender parity index (GPI) in Secondary education in 1972 to that in 1978?
Provide a succinct answer. 0.93. What is the ratio of the Gender parity index (GPI) of Tertiary education in 1972 to that in 1978?
Keep it short and to the point. 0.91. What is the ratio of the Gender parity index (GPI) of Primary education in 1972 to that in 1979?
Give a very brief answer. 0.95. What is the ratio of the Gender parity index (GPI) in Secondary education in 1972 to that in 1979?
Ensure brevity in your answer.  0.92. What is the ratio of the Gender parity index (GPI) of Tertiary education in 1972 to that in 1979?
Ensure brevity in your answer.  0.9. What is the ratio of the Gender parity index (GPI) in Primary education in 1973 to that in 1974?
Offer a very short reply. 1. What is the ratio of the Gender parity index (GPI) in Secondary education in 1973 to that in 1974?
Keep it short and to the point. 0.98. What is the ratio of the Gender parity index (GPI) of Tertiary education in 1973 to that in 1974?
Give a very brief answer. 0.98. What is the ratio of the Gender parity index (GPI) in Secondary education in 1973 to that in 1975?
Provide a short and direct response. 0.97. What is the ratio of the Gender parity index (GPI) of Tertiary education in 1973 to that in 1975?
Make the answer very short. 0.97. What is the ratio of the Gender parity index (GPI) in Primary education in 1973 to that in 1976?
Ensure brevity in your answer.  0.95. What is the ratio of the Gender parity index (GPI) in Secondary education in 1973 to that in 1976?
Your response must be concise. 0.96. What is the ratio of the Gender parity index (GPI) in Tertiary education in 1973 to that in 1976?
Keep it short and to the point. 0.97. What is the ratio of the Gender parity index (GPI) in Primary education in 1973 to that in 1977?
Your response must be concise. 0.94. What is the ratio of the Gender parity index (GPI) of Secondary education in 1973 to that in 1977?
Offer a terse response. 0.96. What is the ratio of the Gender parity index (GPI) in Tertiary education in 1973 to that in 1977?
Your answer should be very brief. 0.94. What is the ratio of the Gender parity index (GPI) in Primary education in 1973 to that in 1978?
Make the answer very short. 0.94. What is the ratio of the Gender parity index (GPI) of Secondary education in 1973 to that in 1978?
Ensure brevity in your answer.  0.94. What is the ratio of the Gender parity index (GPI) in Tertiary education in 1973 to that in 1978?
Provide a succinct answer. 0.93. What is the ratio of the Gender parity index (GPI) of Primary education in 1973 to that in 1979?
Offer a very short reply. 0.94. What is the ratio of the Gender parity index (GPI) of Secondary education in 1973 to that in 1979?
Your response must be concise. 0.93. What is the ratio of the Gender parity index (GPI) in Tertiary education in 1973 to that in 1979?
Offer a terse response. 0.92. What is the ratio of the Gender parity index (GPI) in Primary education in 1974 to that in 1975?
Make the answer very short. 0.96. What is the ratio of the Gender parity index (GPI) of Secondary education in 1974 to that in 1975?
Offer a very short reply. 0.98. What is the ratio of the Gender parity index (GPI) of Tertiary education in 1974 to that in 1975?
Your answer should be very brief. 0.99. What is the ratio of the Gender parity index (GPI) of Primary education in 1974 to that in 1976?
Provide a succinct answer. 0.94. What is the ratio of the Gender parity index (GPI) in Secondary education in 1974 to that in 1976?
Offer a very short reply. 0.98. What is the ratio of the Gender parity index (GPI) in Primary education in 1974 to that in 1977?
Provide a short and direct response. 0.94. What is the ratio of the Gender parity index (GPI) in Secondary education in 1974 to that in 1977?
Your answer should be compact. 0.97. What is the ratio of the Gender parity index (GPI) in Tertiary education in 1974 to that in 1977?
Make the answer very short. 0.95. What is the ratio of the Gender parity index (GPI) in Primary education in 1974 to that in 1978?
Keep it short and to the point. 0.94. What is the ratio of the Gender parity index (GPI) in Secondary education in 1974 to that in 1978?
Your answer should be very brief. 0.96. What is the ratio of the Gender parity index (GPI) in Tertiary education in 1974 to that in 1978?
Provide a short and direct response. 0.94. What is the ratio of the Gender parity index (GPI) in Primary education in 1974 to that in 1979?
Make the answer very short. 0.94. What is the ratio of the Gender parity index (GPI) of Secondary education in 1974 to that in 1979?
Provide a short and direct response. 0.95. What is the ratio of the Gender parity index (GPI) of Tertiary education in 1974 to that in 1979?
Your response must be concise. 0.93. What is the ratio of the Gender parity index (GPI) of Primary education in 1975 to that in 1976?
Keep it short and to the point. 0.98. What is the ratio of the Gender parity index (GPI) in Secondary education in 1975 to that in 1976?
Keep it short and to the point. 0.99. What is the ratio of the Gender parity index (GPI) of Tertiary education in 1975 to that in 1977?
Provide a succinct answer. 0.97. What is the ratio of the Gender parity index (GPI) of Primary education in 1975 to that in 1978?
Give a very brief answer. 0.97. What is the ratio of the Gender parity index (GPI) of Secondary education in 1975 to that in 1978?
Offer a terse response. 0.97. What is the ratio of the Gender parity index (GPI) of Tertiary education in 1975 to that in 1978?
Offer a very short reply. 0.96. What is the ratio of the Gender parity index (GPI) of Primary education in 1975 to that in 1979?
Make the answer very short. 0.97. What is the ratio of the Gender parity index (GPI) of Secondary education in 1975 to that in 1979?
Ensure brevity in your answer.  0.96. What is the ratio of the Gender parity index (GPI) in Tertiary education in 1975 to that in 1979?
Your answer should be compact. 0.95. What is the ratio of the Gender parity index (GPI) of Primary education in 1976 to that in 1977?
Provide a succinct answer. 0.99. What is the ratio of the Gender parity index (GPI) of Secondary education in 1976 to that in 1977?
Your response must be concise. 0.99. What is the ratio of the Gender parity index (GPI) of Tertiary education in 1976 to that in 1977?
Offer a terse response. 0.97. What is the ratio of the Gender parity index (GPI) of Secondary education in 1976 to that in 1978?
Your answer should be very brief. 0.98. What is the ratio of the Gender parity index (GPI) of Tertiary education in 1976 to that in 1978?
Ensure brevity in your answer.  0.96. What is the ratio of the Gender parity index (GPI) of Secondary education in 1976 to that in 1979?
Provide a short and direct response. 0.97. What is the ratio of the Gender parity index (GPI) of Tertiary education in 1976 to that in 1979?
Provide a succinct answer. 0.95. What is the ratio of the Gender parity index (GPI) in Primary education in 1977 to that in 1978?
Your answer should be very brief. 1. What is the ratio of the Gender parity index (GPI) in Secondary education in 1977 to that in 1978?
Make the answer very short. 0.98. What is the ratio of the Gender parity index (GPI) of Tertiary education in 1977 to that in 1978?
Offer a very short reply. 0.99. What is the ratio of the Gender parity index (GPI) in Primary education in 1977 to that in 1979?
Keep it short and to the point. 1. What is the ratio of the Gender parity index (GPI) in Secondary education in 1977 to that in 1979?
Offer a very short reply. 0.98. What is the ratio of the Gender parity index (GPI) in Tertiary education in 1977 to that in 1979?
Offer a terse response. 0.98. What is the ratio of the Gender parity index (GPI) in Secondary education in 1978 to that in 1979?
Your answer should be compact. 0.99. What is the difference between the highest and the second highest Gender parity index (GPI) of Primary education?
Make the answer very short. 0. What is the difference between the highest and the second highest Gender parity index (GPI) of Secondary education?
Your answer should be compact. 0.01. What is the difference between the highest and the second highest Gender parity index (GPI) in Tertiary education?
Provide a short and direct response. 0.01. What is the difference between the highest and the lowest Gender parity index (GPI) in Primary education?
Provide a succinct answer. 0.05. What is the difference between the highest and the lowest Gender parity index (GPI) of Secondary education?
Your response must be concise. 0.06. What is the difference between the highest and the lowest Gender parity index (GPI) of Tertiary education?
Offer a terse response. 0.09. 